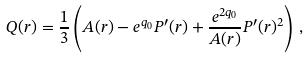<formula> <loc_0><loc_0><loc_500><loc_500>Q ( r ) = \frac { 1 } { 3 } \left ( A ( r ) - e ^ { q _ { 0 } } P ^ { \prime } ( r ) + \frac { e ^ { 2 q _ { 0 } } } { A ( r ) } P ^ { \prime } ( r ) ^ { 2 } \right ) \, ,</formula> 